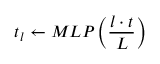Convert formula to latex. <formula><loc_0><loc_0><loc_500><loc_500>t _ { l } \gets M L P \left ( \frac { l \cdot t } { L } \right )</formula> 